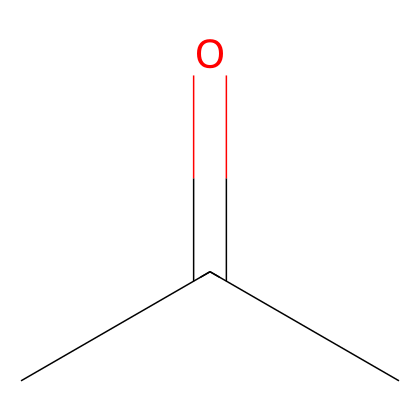What is the name of this chemical? The SMILES representation "CC(=O)C" corresponds to acetone, which is commonly known as dimethyl ketone.
Answer: acetone How many carbon atoms are present in the structure? Analyzing the SMILES, there are three carbon atoms indicated by 'C's. Each 'C' represents one carbon atom in the molecule.
Answer: 3 How many hydrogen atoms are there in this molecule? In the structure, determine the hydrogen atoms by considering that each carbon typically forms four bonds. Acetone has three carbon atoms and based on the structure, there are six hydrogen atoms.
Answer: 6 What type of chemical is acetone classified as? Acetone is identified as a non-electrolyte because it does not dissociate into ions when dissolved in a solvent, thus retaining its molecular integrity.
Answer: non-electrolyte Does acetone have a functional group? The 'C(=O)' in the structure indicates the presence of a carbonyl group, which is characteristic of ketones, confirming that acetone has a functional group.
Answer: yes Why is acetone effective as a solvent in nail polish remover? Acetone's ability to dissolve polar and non-polar substances due to its molecular structure makes it effective for removing substances like nail polish, providing a solvent action based on polarity differences.
Answer: polarity What does the 'C(=O)' part of the structure signify? The 'C(=O)' indicates a carbon atom double-bonded to an oxygen atom, which is the carbonyl group central to ketones, specifically identifying the compound as a ketone.
Answer: carbonyl group 